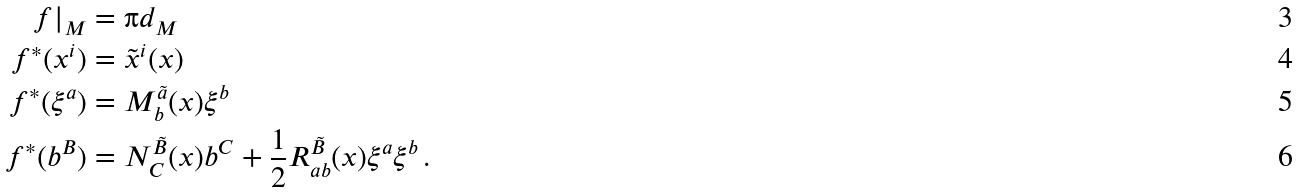Convert formula to latex. <formula><loc_0><loc_0><loc_500><loc_500>f | _ { M } & = \i d _ { M } \\ f ^ { * } ( x ^ { i } ) & = \tilde { x } ^ { i } ( x ) \\ f ^ { * } ( \xi ^ { a } ) & = M ^ { \tilde { a } } _ { b } ( x ) \xi ^ { b } \\ f ^ { * } ( b ^ { B } ) & = N ^ { \tilde { B } } _ { C } ( x ) b ^ { C } + \frac { 1 } { 2 } R ^ { \tilde { B } } _ { a b } ( x ) \xi ^ { a } \xi ^ { b } \, .</formula> 